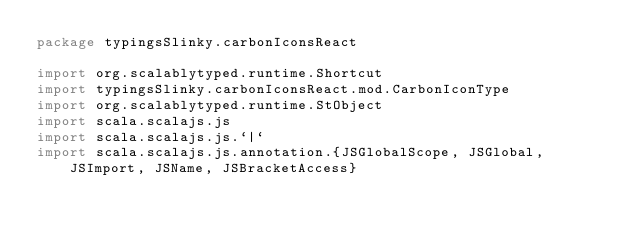Convert code to text. <code><loc_0><loc_0><loc_500><loc_500><_Scala_>package typingsSlinky.carbonIconsReact

import org.scalablytyped.runtime.Shortcut
import typingsSlinky.carbonIconsReact.mod.CarbonIconType
import org.scalablytyped.runtime.StObject
import scala.scalajs.js
import scala.scalajs.js.`|`
import scala.scalajs.js.annotation.{JSGlobalScope, JSGlobal, JSImport, JSName, JSBracketAccess}
</code> 